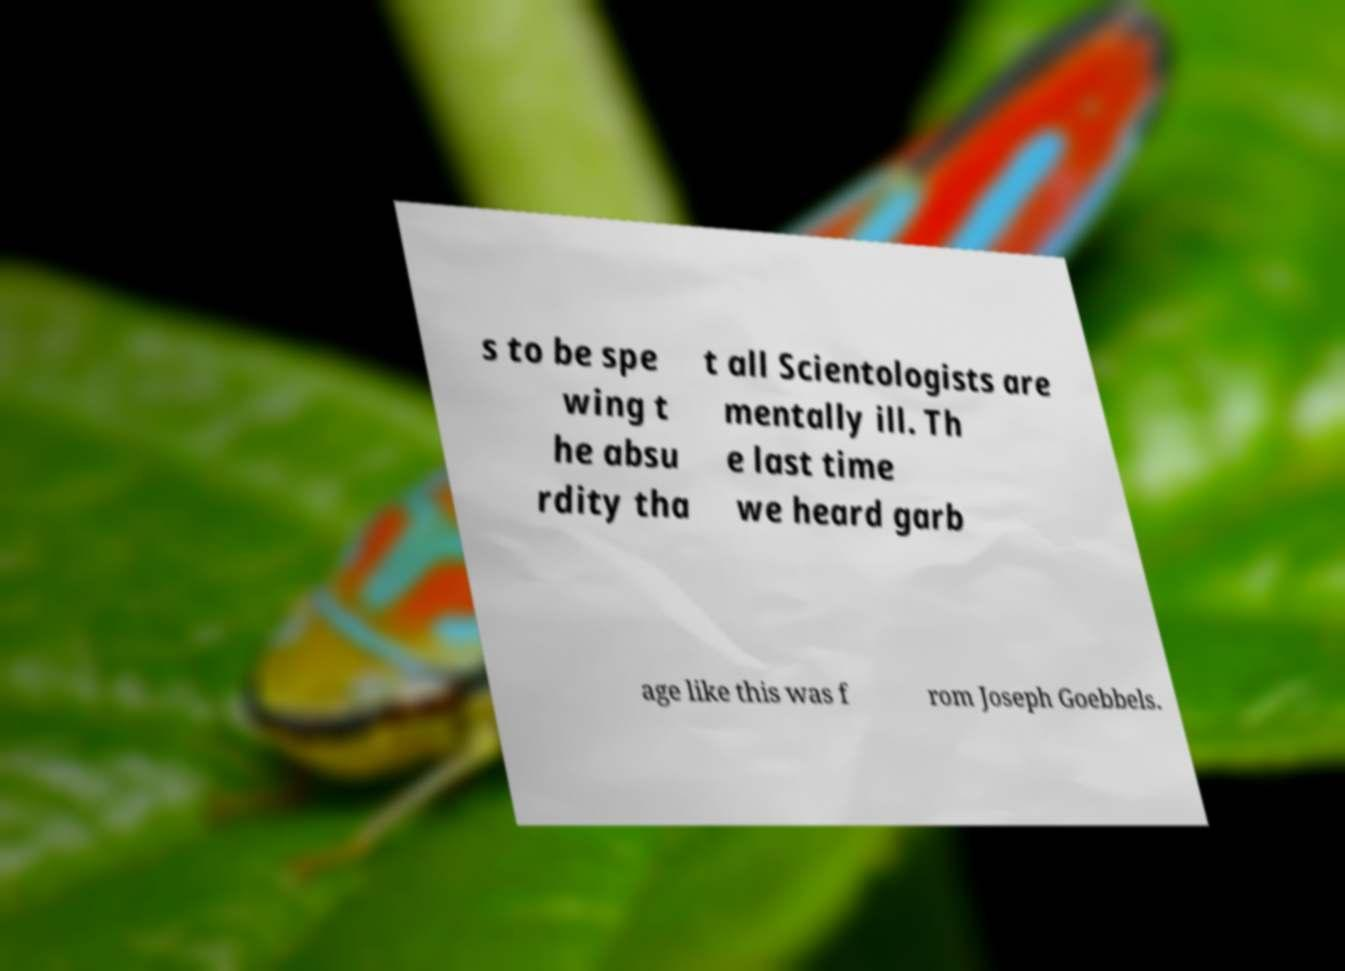What messages or text are displayed in this image? I need them in a readable, typed format. s to be spe wing t he absu rdity tha t all Scientologists are mentally ill. Th e last time we heard garb age like this was f rom Joseph Goebbels. 